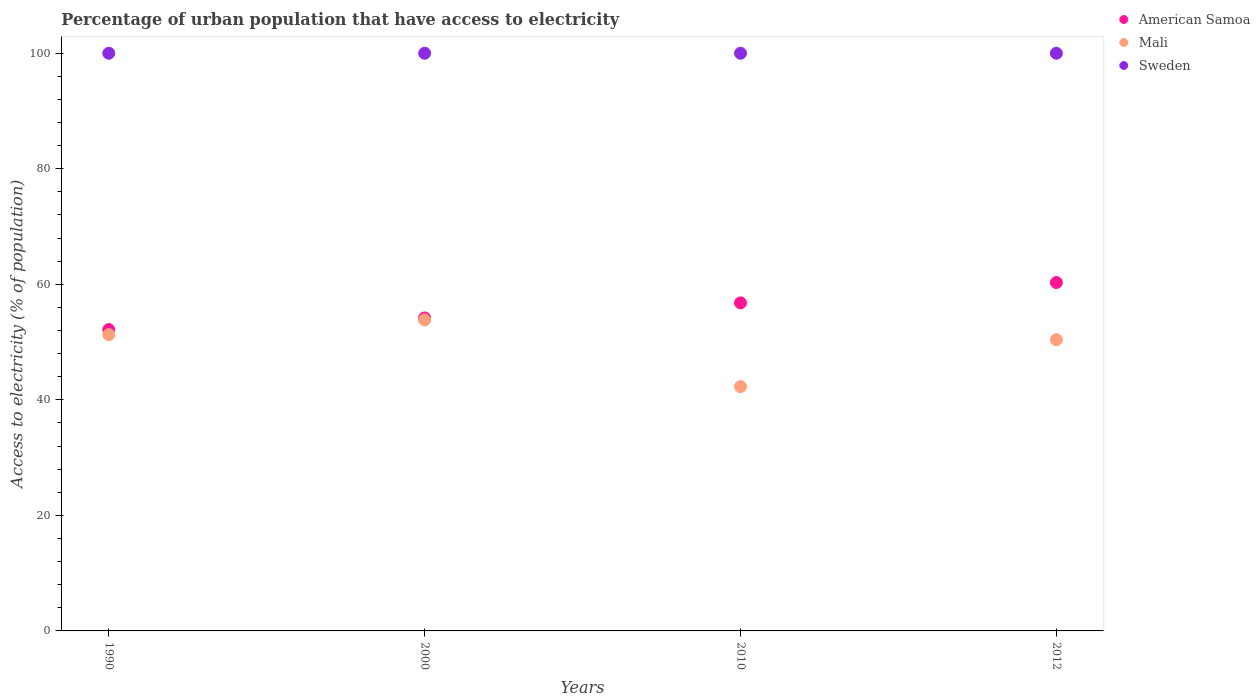Is the number of dotlines equal to the number of legend labels?
Make the answer very short. Yes. What is the percentage of urban population that have access to electricity in Sweden in 1990?
Offer a very short reply. 100. Across all years, what is the maximum percentage of urban population that have access to electricity in American Samoa?
Your answer should be compact. 60.3. Across all years, what is the minimum percentage of urban population that have access to electricity in American Samoa?
Offer a terse response. 52.17. In which year was the percentage of urban population that have access to electricity in Sweden maximum?
Your response must be concise. 1990. What is the total percentage of urban population that have access to electricity in Sweden in the graph?
Your answer should be compact. 400. What is the difference between the percentage of urban population that have access to electricity in Sweden in 1990 and that in 2010?
Offer a very short reply. 0. What is the difference between the percentage of urban population that have access to electricity in American Samoa in 2000 and the percentage of urban population that have access to electricity in Mali in 1990?
Offer a terse response. 2.89. What is the average percentage of urban population that have access to electricity in Mali per year?
Provide a succinct answer. 49.46. In the year 1990, what is the difference between the percentage of urban population that have access to electricity in Sweden and percentage of urban population that have access to electricity in Mali?
Your response must be concise. 48.71. What is the ratio of the percentage of urban population that have access to electricity in Sweden in 2000 to that in 2010?
Ensure brevity in your answer.  1. Is the difference between the percentage of urban population that have access to electricity in Sweden in 1990 and 2012 greater than the difference between the percentage of urban population that have access to electricity in Mali in 1990 and 2012?
Your answer should be very brief. No. What is the difference between the highest and the lowest percentage of urban population that have access to electricity in Mali?
Keep it short and to the point. 11.55. In how many years, is the percentage of urban population that have access to electricity in American Samoa greater than the average percentage of urban population that have access to electricity in American Samoa taken over all years?
Your answer should be compact. 2. Is the sum of the percentage of urban population that have access to electricity in Mali in 1990 and 2000 greater than the maximum percentage of urban population that have access to electricity in American Samoa across all years?
Offer a terse response. Yes. Is it the case that in every year, the sum of the percentage of urban population that have access to electricity in Mali and percentage of urban population that have access to electricity in Sweden  is greater than the percentage of urban population that have access to electricity in American Samoa?
Your answer should be very brief. Yes. Does the percentage of urban population that have access to electricity in Sweden monotonically increase over the years?
Your response must be concise. No. How many dotlines are there?
Ensure brevity in your answer.  3. What is the difference between two consecutive major ticks on the Y-axis?
Ensure brevity in your answer.  20. Are the values on the major ticks of Y-axis written in scientific E-notation?
Make the answer very short. No. Does the graph contain any zero values?
Ensure brevity in your answer.  No. How many legend labels are there?
Provide a short and direct response. 3. How are the legend labels stacked?
Your answer should be very brief. Vertical. What is the title of the graph?
Offer a very short reply. Percentage of urban population that have access to electricity. What is the label or title of the X-axis?
Your answer should be compact. Years. What is the label or title of the Y-axis?
Offer a very short reply. Access to electricity (% of population). What is the Access to electricity (% of population) in American Samoa in 1990?
Your response must be concise. 52.17. What is the Access to electricity (% of population) of Mali in 1990?
Ensure brevity in your answer.  51.29. What is the Access to electricity (% of population) in Sweden in 1990?
Keep it short and to the point. 100. What is the Access to electricity (% of population) in American Samoa in 2000?
Give a very brief answer. 54.18. What is the Access to electricity (% of population) of Mali in 2000?
Your answer should be compact. 53.84. What is the Access to electricity (% of population) of American Samoa in 2010?
Give a very brief answer. 56.79. What is the Access to electricity (% of population) of Mali in 2010?
Provide a succinct answer. 42.29. What is the Access to electricity (% of population) of American Samoa in 2012?
Give a very brief answer. 60.3. What is the Access to electricity (% of population) in Mali in 2012?
Offer a very short reply. 50.41. Across all years, what is the maximum Access to electricity (% of population) of American Samoa?
Keep it short and to the point. 60.3. Across all years, what is the maximum Access to electricity (% of population) of Mali?
Your answer should be very brief. 53.84. Across all years, what is the maximum Access to electricity (% of population) in Sweden?
Your answer should be compact. 100. Across all years, what is the minimum Access to electricity (% of population) of American Samoa?
Ensure brevity in your answer.  52.17. Across all years, what is the minimum Access to electricity (% of population) of Mali?
Provide a short and direct response. 42.29. What is the total Access to electricity (% of population) in American Samoa in the graph?
Ensure brevity in your answer.  223.44. What is the total Access to electricity (% of population) in Mali in the graph?
Your answer should be very brief. 197.83. What is the difference between the Access to electricity (% of population) of American Samoa in 1990 and that in 2000?
Your answer should be very brief. -2.01. What is the difference between the Access to electricity (% of population) of Mali in 1990 and that in 2000?
Ensure brevity in your answer.  -2.56. What is the difference between the Access to electricity (% of population) in Sweden in 1990 and that in 2000?
Ensure brevity in your answer.  0. What is the difference between the Access to electricity (% of population) in American Samoa in 1990 and that in 2010?
Keep it short and to the point. -4.62. What is the difference between the Access to electricity (% of population) of Mali in 1990 and that in 2010?
Make the answer very short. 8.99. What is the difference between the Access to electricity (% of population) in American Samoa in 1990 and that in 2012?
Provide a succinct answer. -8.14. What is the difference between the Access to electricity (% of population) of Mali in 1990 and that in 2012?
Ensure brevity in your answer.  0.88. What is the difference between the Access to electricity (% of population) in Sweden in 1990 and that in 2012?
Offer a terse response. 0. What is the difference between the Access to electricity (% of population) of American Samoa in 2000 and that in 2010?
Offer a very short reply. -2.61. What is the difference between the Access to electricity (% of population) in Mali in 2000 and that in 2010?
Keep it short and to the point. 11.55. What is the difference between the Access to electricity (% of population) in American Samoa in 2000 and that in 2012?
Provide a short and direct response. -6.13. What is the difference between the Access to electricity (% of population) of Mali in 2000 and that in 2012?
Keep it short and to the point. 3.43. What is the difference between the Access to electricity (% of population) in Sweden in 2000 and that in 2012?
Offer a terse response. 0. What is the difference between the Access to electricity (% of population) of American Samoa in 2010 and that in 2012?
Keep it short and to the point. -3.52. What is the difference between the Access to electricity (% of population) in Mali in 2010 and that in 2012?
Provide a short and direct response. -8.12. What is the difference between the Access to electricity (% of population) in Sweden in 2010 and that in 2012?
Ensure brevity in your answer.  0. What is the difference between the Access to electricity (% of population) in American Samoa in 1990 and the Access to electricity (% of population) in Mali in 2000?
Offer a very short reply. -1.67. What is the difference between the Access to electricity (% of population) of American Samoa in 1990 and the Access to electricity (% of population) of Sweden in 2000?
Keep it short and to the point. -47.83. What is the difference between the Access to electricity (% of population) of Mali in 1990 and the Access to electricity (% of population) of Sweden in 2000?
Provide a succinct answer. -48.71. What is the difference between the Access to electricity (% of population) of American Samoa in 1990 and the Access to electricity (% of population) of Mali in 2010?
Your answer should be very brief. 9.87. What is the difference between the Access to electricity (% of population) of American Samoa in 1990 and the Access to electricity (% of population) of Sweden in 2010?
Ensure brevity in your answer.  -47.83. What is the difference between the Access to electricity (% of population) in Mali in 1990 and the Access to electricity (% of population) in Sweden in 2010?
Your response must be concise. -48.71. What is the difference between the Access to electricity (% of population) of American Samoa in 1990 and the Access to electricity (% of population) of Mali in 2012?
Offer a terse response. 1.76. What is the difference between the Access to electricity (% of population) of American Samoa in 1990 and the Access to electricity (% of population) of Sweden in 2012?
Offer a terse response. -47.83. What is the difference between the Access to electricity (% of population) of Mali in 1990 and the Access to electricity (% of population) of Sweden in 2012?
Keep it short and to the point. -48.71. What is the difference between the Access to electricity (% of population) of American Samoa in 2000 and the Access to electricity (% of population) of Mali in 2010?
Give a very brief answer. 11.88. What is the difference between the Access to electricity (% of population) of American Samoa in 2000 and the Access to electricity (% of population) of Sweden in 2010?
Provide a short and direct response. -45.82. What is the difference between the Access to electricity (% of population) of Mali in 2000 and the Access to electricity (% of population) of Sweden in 2010?
Offer a very short reply. -46.16. What is the difference between the Access to electricity (% of population) in American Samoa in 2000 and the Access to electricity (% of population) in Mali in 2012?
Provide a succinct answer. 3.77. What is the difference between the Access to electricity (% of population) in American Samoa in 2000 and the Access to electricity (% of population) in Sweden in 2012?
Provide a succinct answer. -45.82. What is the difference between the Access to electricity (% of population) in Mali in 2000 and the Access to electricity (% of population) in Sweden in 2012?
Make the answer very short. -46.16. What is the difference between the Access to electricity (% of population) of American Samoa in 2010 and the Access to electricity (% of population) of Mali in 2012?
Your response must be concise. 6.38. What is the difference between the Access to electricity (% of population) of American Samoa in 2010 and the Access to electricity (% of population) of Sweden in 2012?
Make the answer very short. -43.21. What is the difference between the Access to electricity (% of population) in Mali in 2010 and the Access to electricity (% of population) in Sweden in 2012?
Make the answer very short. -57.71. What is the average Access to electricity (% of population) in American Samoa per year?
Provide a succinct answer. 55.86. What is the average Access to electricity (% of population) of Mali per year?
Your answer should be very brief. 49.46. What is the average Access to electricity (% of population) of Sweden per year?
Make the answer very short. 100. In the year 1990, what is the difference between the Access to electricity (% of population) of American Samoa and Access to electricity (% of population) of Mali?
Give a very brief answer. 0.88. In the year 1990, what is the difference between the Access to electricity (% of population) in American Samoa and Access to electricity (% of population) in Sweden?
Your response must be concise. -47.83. In the year 1990, what is the difference between the Access to electricity (% of population) in Mali and Access to electricity (% of population) in Sweden?
Your answer should be very brief. -48.71. In the year 2000, what is the difference between the Access to electricity (% of population) in American Samoa and Access to electricity (% of population) in Mali?
Provide a short and direct response. 0.33. In the year 2000, what is the difference between the Access to electricity (% of population) of American Samoa and Access to electricity (% of population) of Sweden?
Give a very brief answer. -45.82. In the year 2000, what is the difference between the Access to electricity (% of population) in Mali and Access to electricity (% of population) in Sweden?
Keep it short and to the point. -46.16. In the year 2010, what is the difference between the Access to electricity (% of population) in American Samoa and Access to electricity (% of population) in Mali?
Keep it short and to the point. 14.5. In the year 2010, what is the difference between the Access to electricity (% of population) of American Samoa and Access to electricity (% of population) of Sweden?
Make the answer very short. -43.21. In the year 2010, what is the difference between the Access to electricity (% of population) in Mali and Access to electricity (% of population) in Sweden?
Provide a succinct answer. -57.71. In the year 2012, what is the difference between the Access to electricity (% of population) in American Samoa and Access to electricity (% of population) in Mali?
Your answer should be very brief. 9.89. In the year 2012, what is the difference between the Access to electricity (% of population) of American Samoa and Access to electricity (% of population) of Sweden?
Keep it short and to the point. -39.7. In the year 2012, what is the difference between the Access to electricity (% of population) of Mali and Access to electricity (% of population) of Sweden?
Your answer should be compact. -49.59. What is the ratio of the Access to electricity (% of population) of American Samoa in 1990 to that in 2000?
Your answer should be compact. 0.96. What is the ratio of the Access to electricity (% of population) of Mali in 1990 to that in 2000?
Your answer should be very brief. 0.95. What is the ratio of the Access to electricity (% of population) in American Samoa in 1990 to that in 2010?
Keep it short and to the point. 0.92. What is the ratio of the Access to electricity (% of population) in Mali in 1990 to that in 2010?
Ensure brevity in your answer.  1.21. What is the ratio of the Access to electricity (% of population) of American Samoa in 1990 to that in 2012?
Offer a very short reply. 0.87. What is the ratio of the Access to electricity (% of population) of Mali in 1990 to that in 2012?
Ensure brevity in your answer.  1.02. What is the ratio of the Access to electricity (% of population) in American Samoa in 2000 to that in 2010?
Give a very brief answer. 0.95. What is the ratio of the Access to electricity (% of population) of Mali in 2000 to that in 2010?
Keep it short and to the point. 1.27. What is the ratio of the Access to electricity (% of population) in Sweden in 2000 to that in 2010?
Offer a terse response. 1. What is the ratio of the Access to electricity (% of population) in American Samoa in 2000 to that in 2012?
Make the answer very short. 0.9. What is the ratio of the Access to electricity (% of population) of Mali in 2000 to that in 2012?
Make the answer very short. 1.07. What is the ratio of the Access to electricity (% of population) of Sweden in 2000 to that in 2012?
Ensure brevity in your answer.  1. What is the ratio of the Access to electricity (% of population) of American Samoa in 2010 to that in 2012?
Offer a very short reply. 0.94. What is the ratio of the Access to electricity (% of population) in Mali in 2010 to that in 2012?
Make the answer very short. 0.84. What is the difference between the highest and the second highest Access to electricity (% of population) in American Samoa?
Offer a very short reply. 3.52. What is the difference between the highest and the second highest Access to electricity (% of population) of Mali?
Ensure brevity in your answer.  2.56. What is the difference between the highest and the lowest Access to electricity (% of population) of American Samoa?
Provide a short and direct response. 8.14. What is the difference between the highest and the lowest Access to electricity (% of population) in Mali?
Make the answer very short. 11.55. 